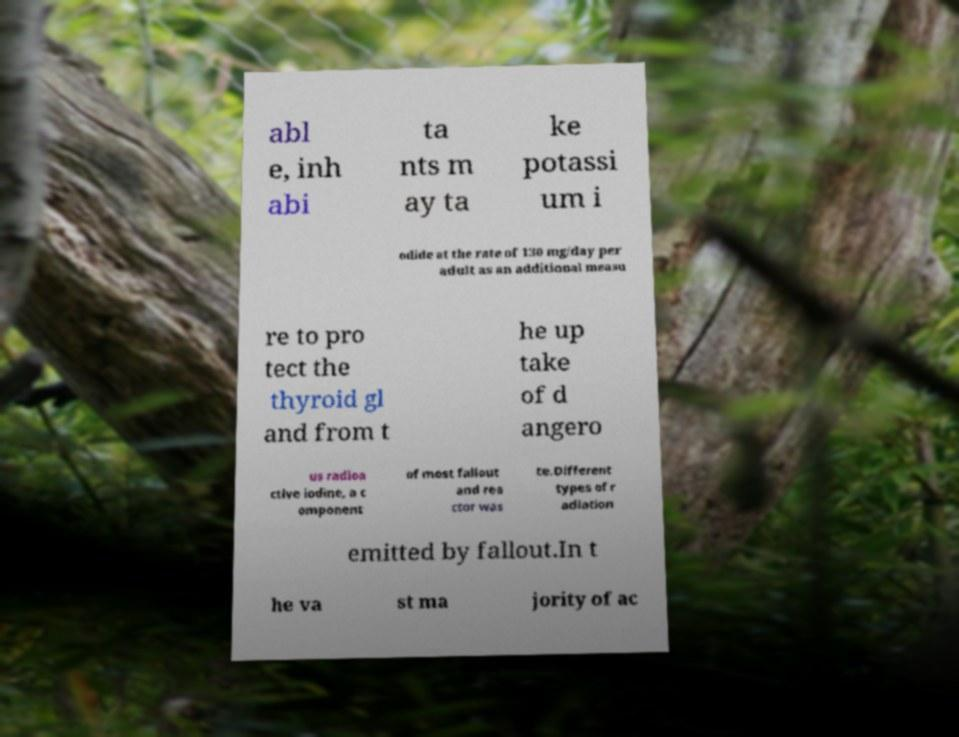Could you assist in decoding the text presented in this image and type it out clearly? abl e, inh abi ta nts m ay ta ke potassi um i odide at the rate of 130 mg/day per adult as an additional measu re to pro tect the thyroid gl and from t he up take of d angero us radioa ctive iodine, a c omponent of most fallout and rea ctor was te.Different types of r adiation emitted by fallout.In t he va st ma jority of ac 